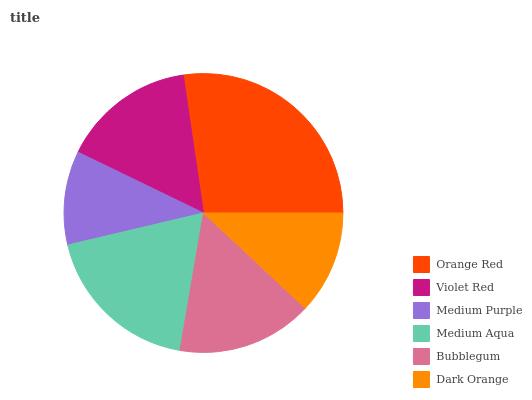Is Medium Purple the minimum?
Answer yes or no. Yes. Is Orange Red the maximum?
Answer yes or no. Yes. Is Violet Red the minimum?
Answer yes or no. No. Is Violet Red the maximum?
Answer yes or no. No. Is Orange Red greater than Violet Red?
Answer yes or no. Yes. Is Violet Red less than Orange Red?
Answer yes or no. Yes. Is Violet Red greater than Orange Red?
Answer yes or no. No. Is Orange Red less than Violet Red?
Answer yes or no. No. Is Bubblegum the high median?
Answer yes or no. Yes. Is Violet Red the low median?
Answer yes or no. Yes. Is Medium Purple the high median?
Answer yes or no. No. Is Dark Orange the low median?
Answer yes or no. No. 